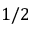Convert formula to latex. <formula><loc_0><loc_0><loc_500><loc_500>1 / 2</formula> 